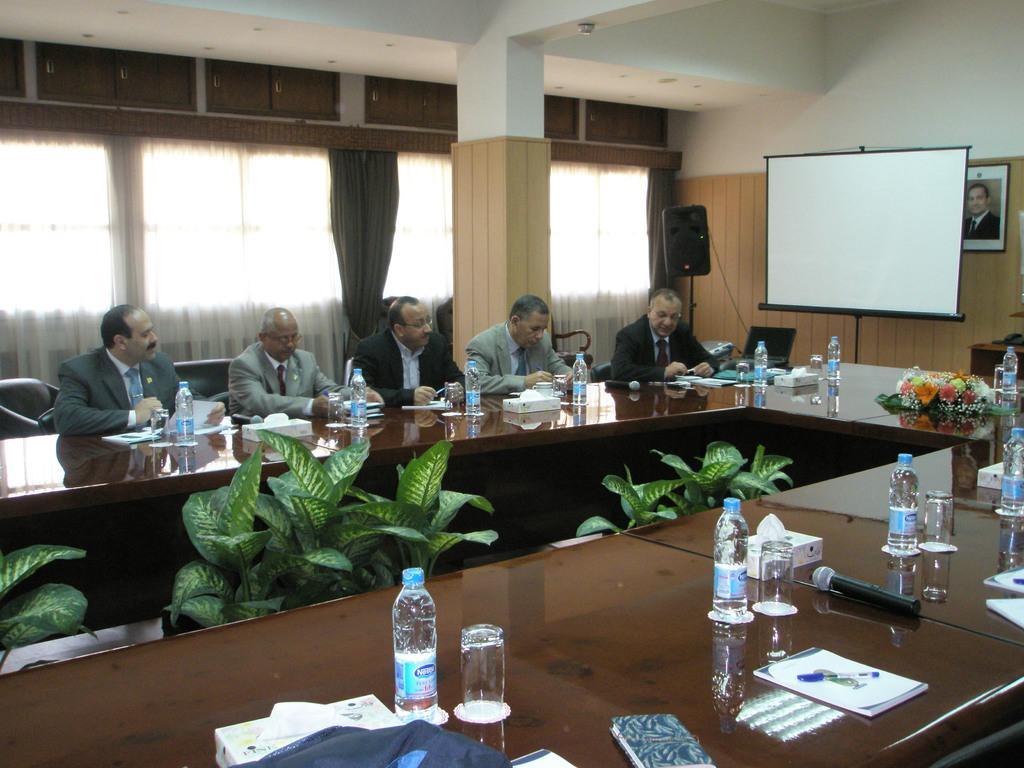Could you give a brief overview of what you see in this image? In this image there are a few men sitting on the chairs at the tables. On the tables there are bottles, glasses, microphones, books, pens, a flower bouquet and tissues. In between the tables there are house plants. To the right there is a board. Behind the board there is a wall. There is a picture frame on the wall. Beside the board there is a speaker on a tripod stand. Behind the men there are curtains to the wall. 